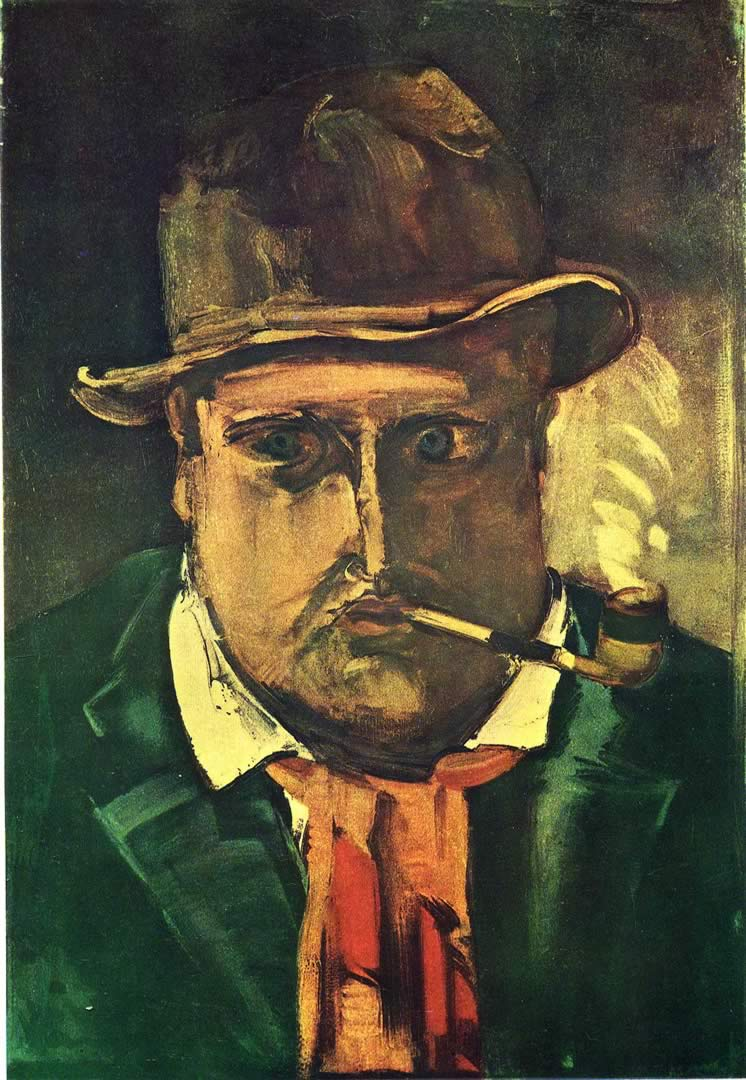Can you tell me more about the artistic techniques used in this painting? The painting employs several notable artistic techniques characteristic of expressionism. The use of a dark, moody color palette with prominent greens and browns sets a somber tone, highlighting the psychological depth of the subject. The artist's brushstrokes are bold and dynamic, adding texture and a sense of movement to the composition. The intentional distortion of the man's features and the exaggerated expression create an emotional intensity that draws the viewer in. The contrasting red and yellow accents provide visual interest and balance, breaking up the darker hues and adding a layer of complexity to the artwork. How do these artistic choices contribute to the overall impact of the painting? These artistic choices significantly enhance the painting's emotional impact. The dark, moody colors set a somber, reflective tone, while the bold brushstrokes and dynamic composition add a sense of urgency and intensity. The exaggerated features and expressions convey strong emotions and psychological depth, inviting viewers to connect with the subject on a deeper level. The contrasting accents of red and yellow provide a striking visual counterpoint, highlighting specific areas of the painting and drawing the viewer's eye across the composition. Together, these elements create a powerful, immersive experience that leaves a lasting impression. If you had to write a short story inspired by this painting, what would it be? In a quaint village by the sea, there lived an old man named Marcellus. Known for his wisdom and his enigmatic presence, Marcellus was always seen with his worn-out hat and a pipe that seemed to tell stories of its own. Every evening, as the sun dipped below the horizon, he would sit by the harbor, staring into the vast expanse of the ocean, lost in thought. Once a renowned sea captain, Marcellus had spent his life battling the relentless waves and discovering new lands. But now, in his twilight years, he found solace in the memories of his adventures. The young children of the village would gather around him, eager to hear tales of mermaids, hidden treasures, and fearsome storms. Yet, behind his captivating stories lay a deep melancholy — a longing for the seas he could no longer traverse. His eyes, though wise, held the weight of countless voyages and unspoken sorrows. Marcellus's story is one of bravery, solitude, and the undying bond between a man and the sea. 